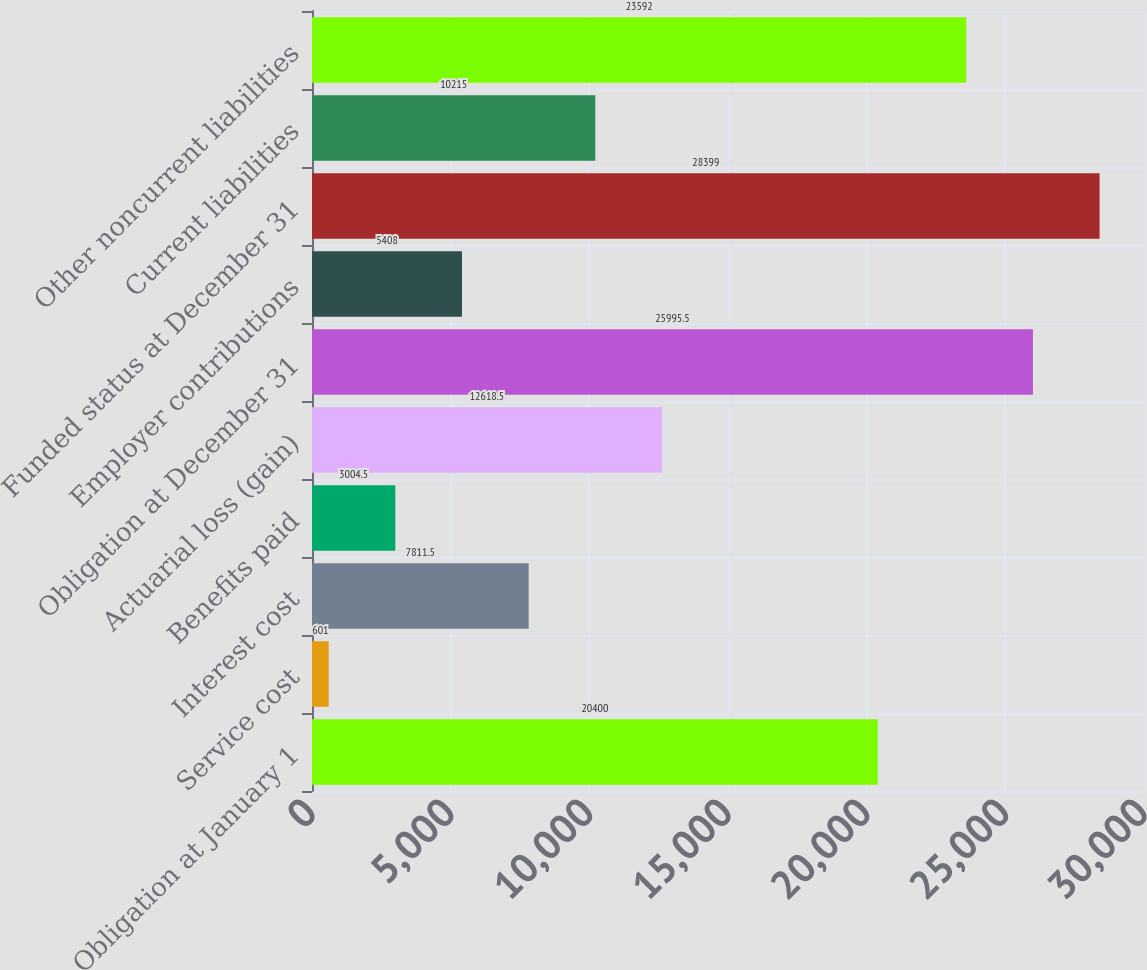<chart> <loc_0><loc_0><loc_500><loc_500><bar_chart><fcel>Obligation at January 1<fcel>Service cost<fcel>Interest cost<fcel>Benefits paid<fcel>Actuarial loss (gain)<fcel>Obligation at December 31<fcel>Employer contributions<fcel>Funded status at December 31<fcel>Current liabilities<fcel>Other noncurrent liabilities<nl><fcel>20400<fcel>601<fcel>7811.5<fcel>3004.5<fcel>12618.5<fcel>25995.5<fcel>5408<fcel>28399<fcel>10215<fcel>23592<nl></chart> 